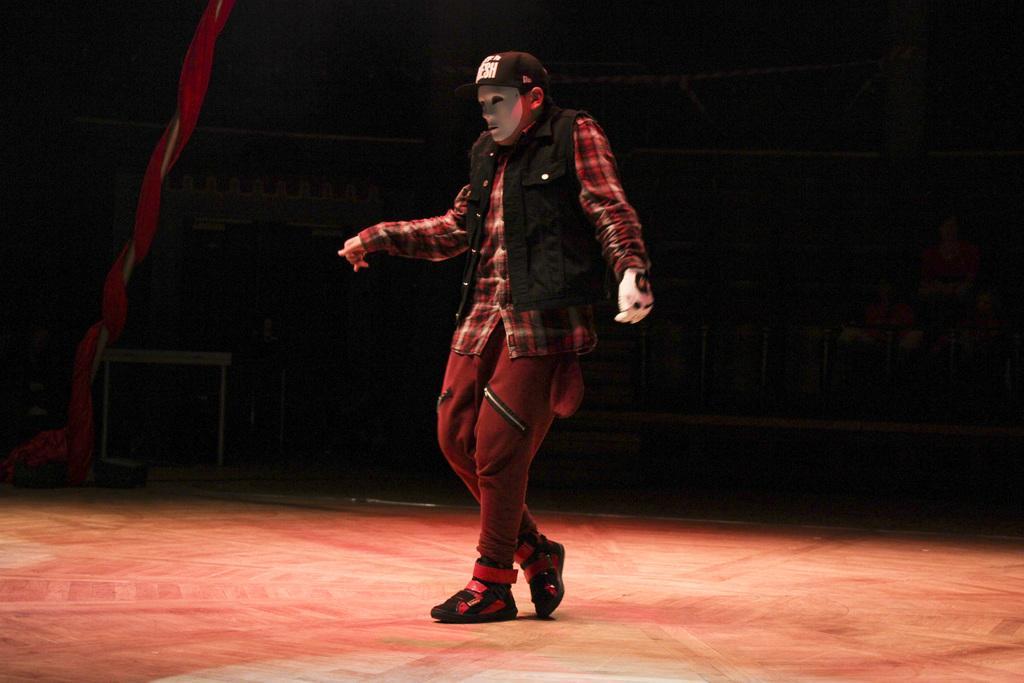Could you give a brief overview of what you see in this image? In this picture we can see a man standing here, this person wore a cap, a mask, a glove and shoes, at the bottom there is a floor, we can see a cloth here. 